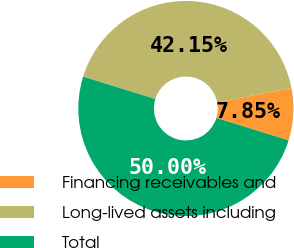Convert chart to OTSL. <chart><loc_0><loc_0><loc_500><loc_500><pie_chart><fcel>Financing receivables and<fcel>Long-lived assets including<fcel>Total<nl><fcel>7.85%<fcel>42.15%<fcel>50.0%<nl></chart> 